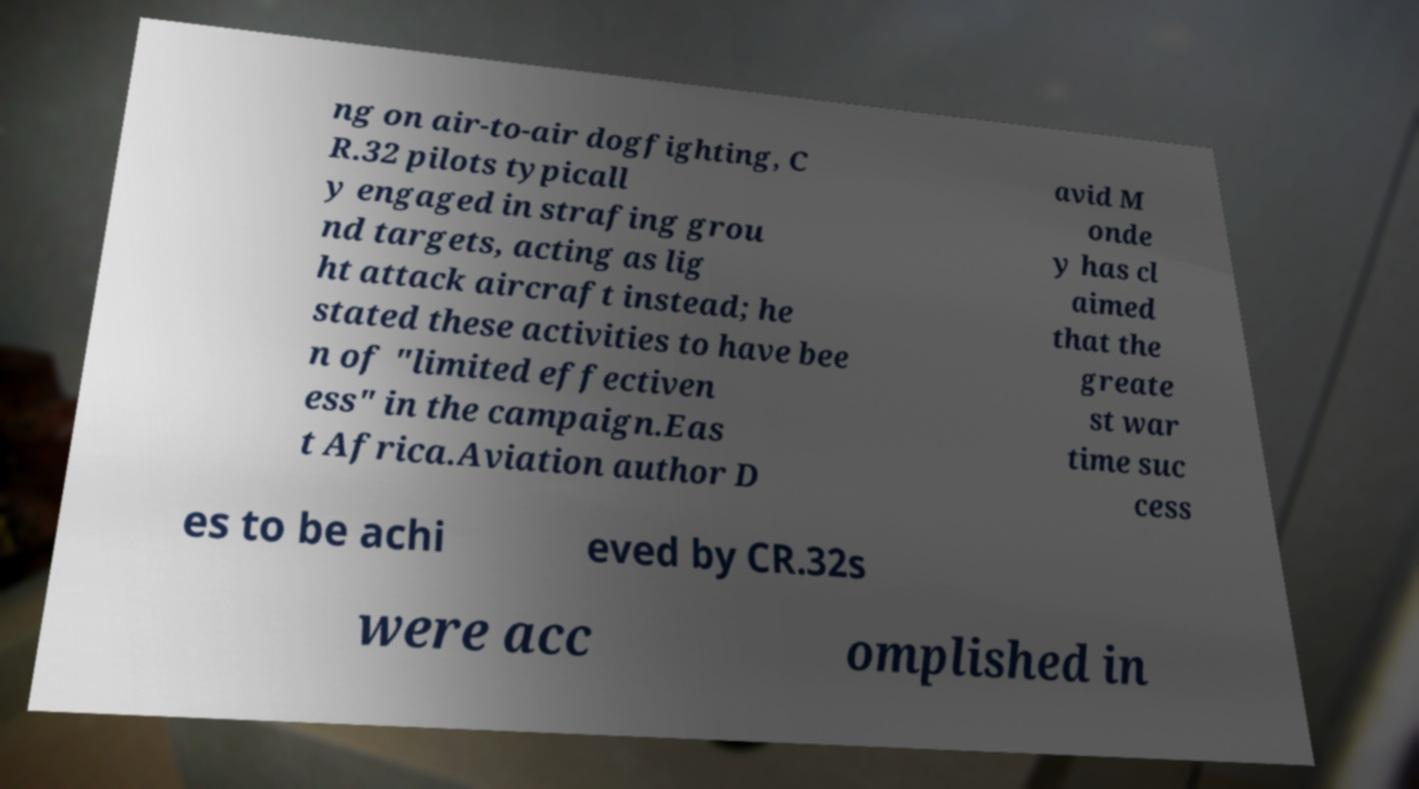Please identify and transcribe the text found in this image. ng on air-to-air dogfighting, C R.32 pilots typicall y engaged in strafing grou nd targets, acting as lig ht attack aircraft instead; he stated these activities to have bee n of "limited effectiven ess" in the campaign.Eas t Africa.Aviation author D avid M onde y has cl aimed that the greate st war time suc cess es to be achi eved by CR.32s were acc omplished in 